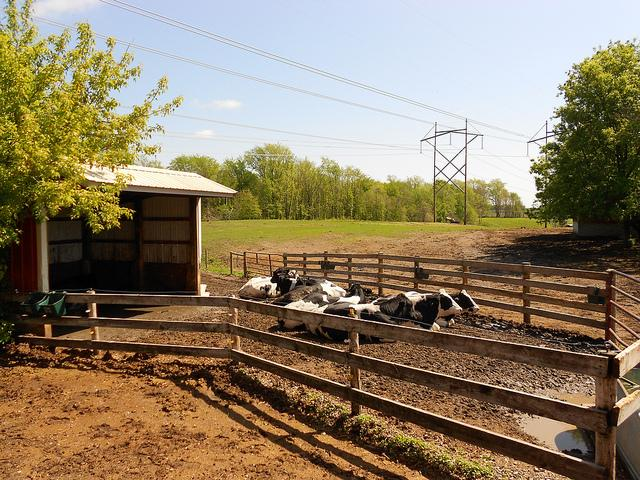What is the large structure in the background? Please explain your reasoning. power lines. A large structure made out of metal holding lines along the sky to other similar structure. 